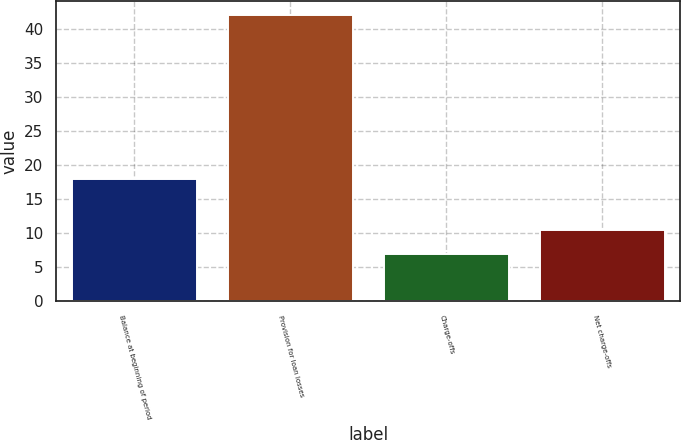Convert chart to OTSL. <chart><loc_0><loc_0><loc_500><loc_500><bar_chart><fcel>Balance at beginning of period<fcel>Provision for loan losses<fcel>Charge-offs<fcel>Net charge-offs<nl><fcel>18<fcel>42<fcel>7<fcel>10.5<nl></chart> 